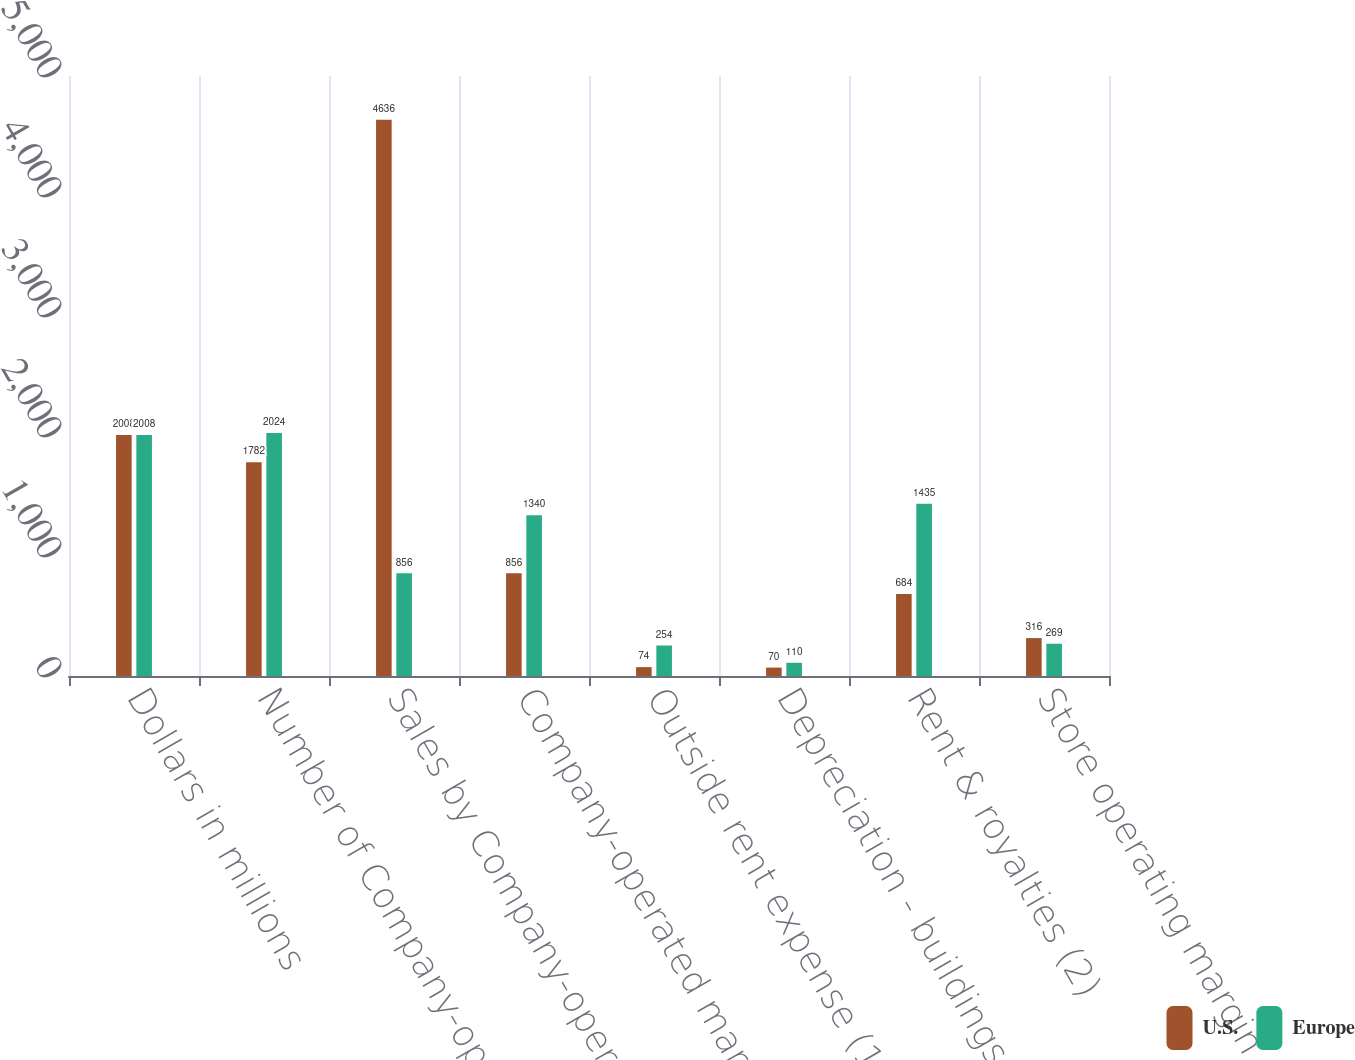<chart> <loc_0><loc_0><loc_500><loc_500><stacked_bar_chart><ecel><fcel>Dollars in millions<fcel>Number of Company-operated<fcel>Sales by Company-operated<fcel>Company-operated margin<fcel>Outside rent expense (1)<fcel>Depreciation - buildings &<fcel>Rent & royalties (2)<fcel>Store operating margin<nl><fcel>U.S.<fcel>2008<fcel>1782<fcel>4636<fcel>856<fcel>74<fcel>70<fcel>684<fcel>316<nl><fcel>Europe<fcel>2008<fcel>2024<fcel>856<fcel>1340<fcel>254<fcel>110<fcel>1435<fcel>269<nl></chart> 